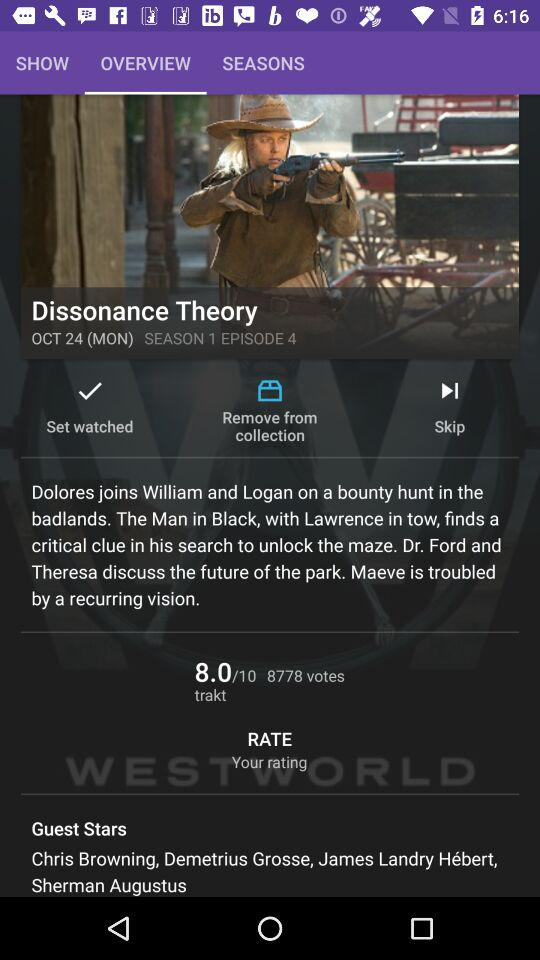Which episode is this? This is episode 4. 